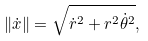Convert formula to latex. <formula><loc_0><loc_0><loc_500><loc_500>\| { \dot { x } } \| = \sqrt { \dot { r } ^ { 2 } + r ^ { 2 } \dot { \theta } ^ { 2 } } ,</formula> 